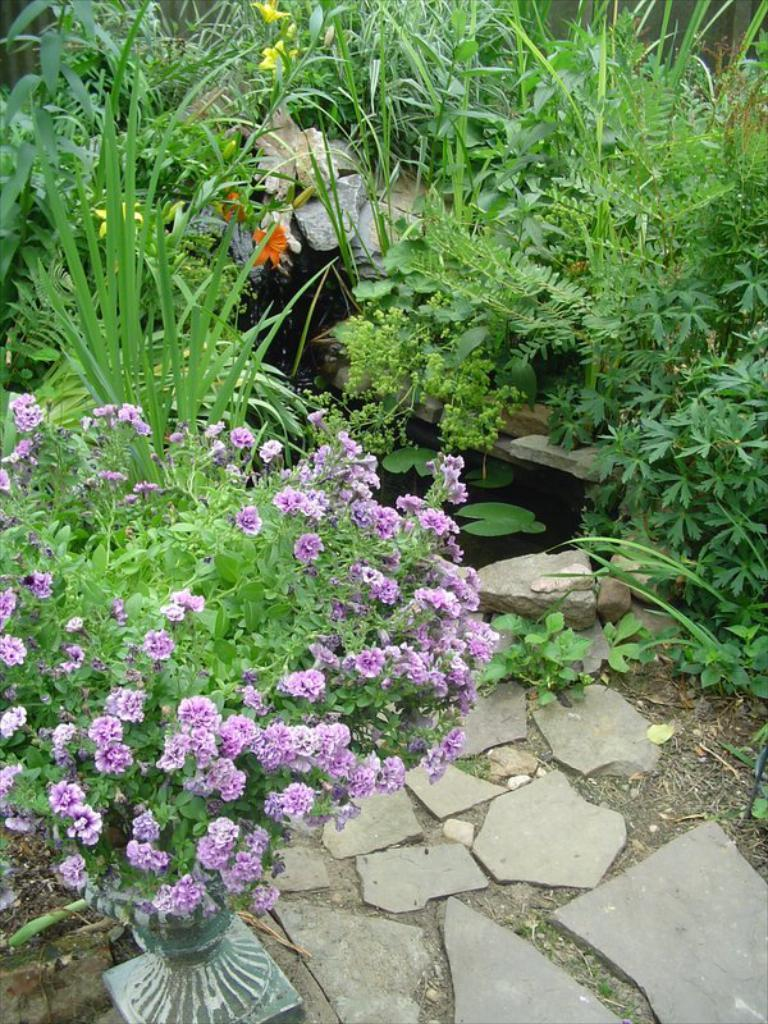What type of vegetation can be seen on the ground in the image? There are many plants on the ground in the image. Can you describe the flowers in the image? There are flowers on a plant on the left side of the image. How many beds can be seen in the image? There are no beds present in the image; it features plants and flowers. 